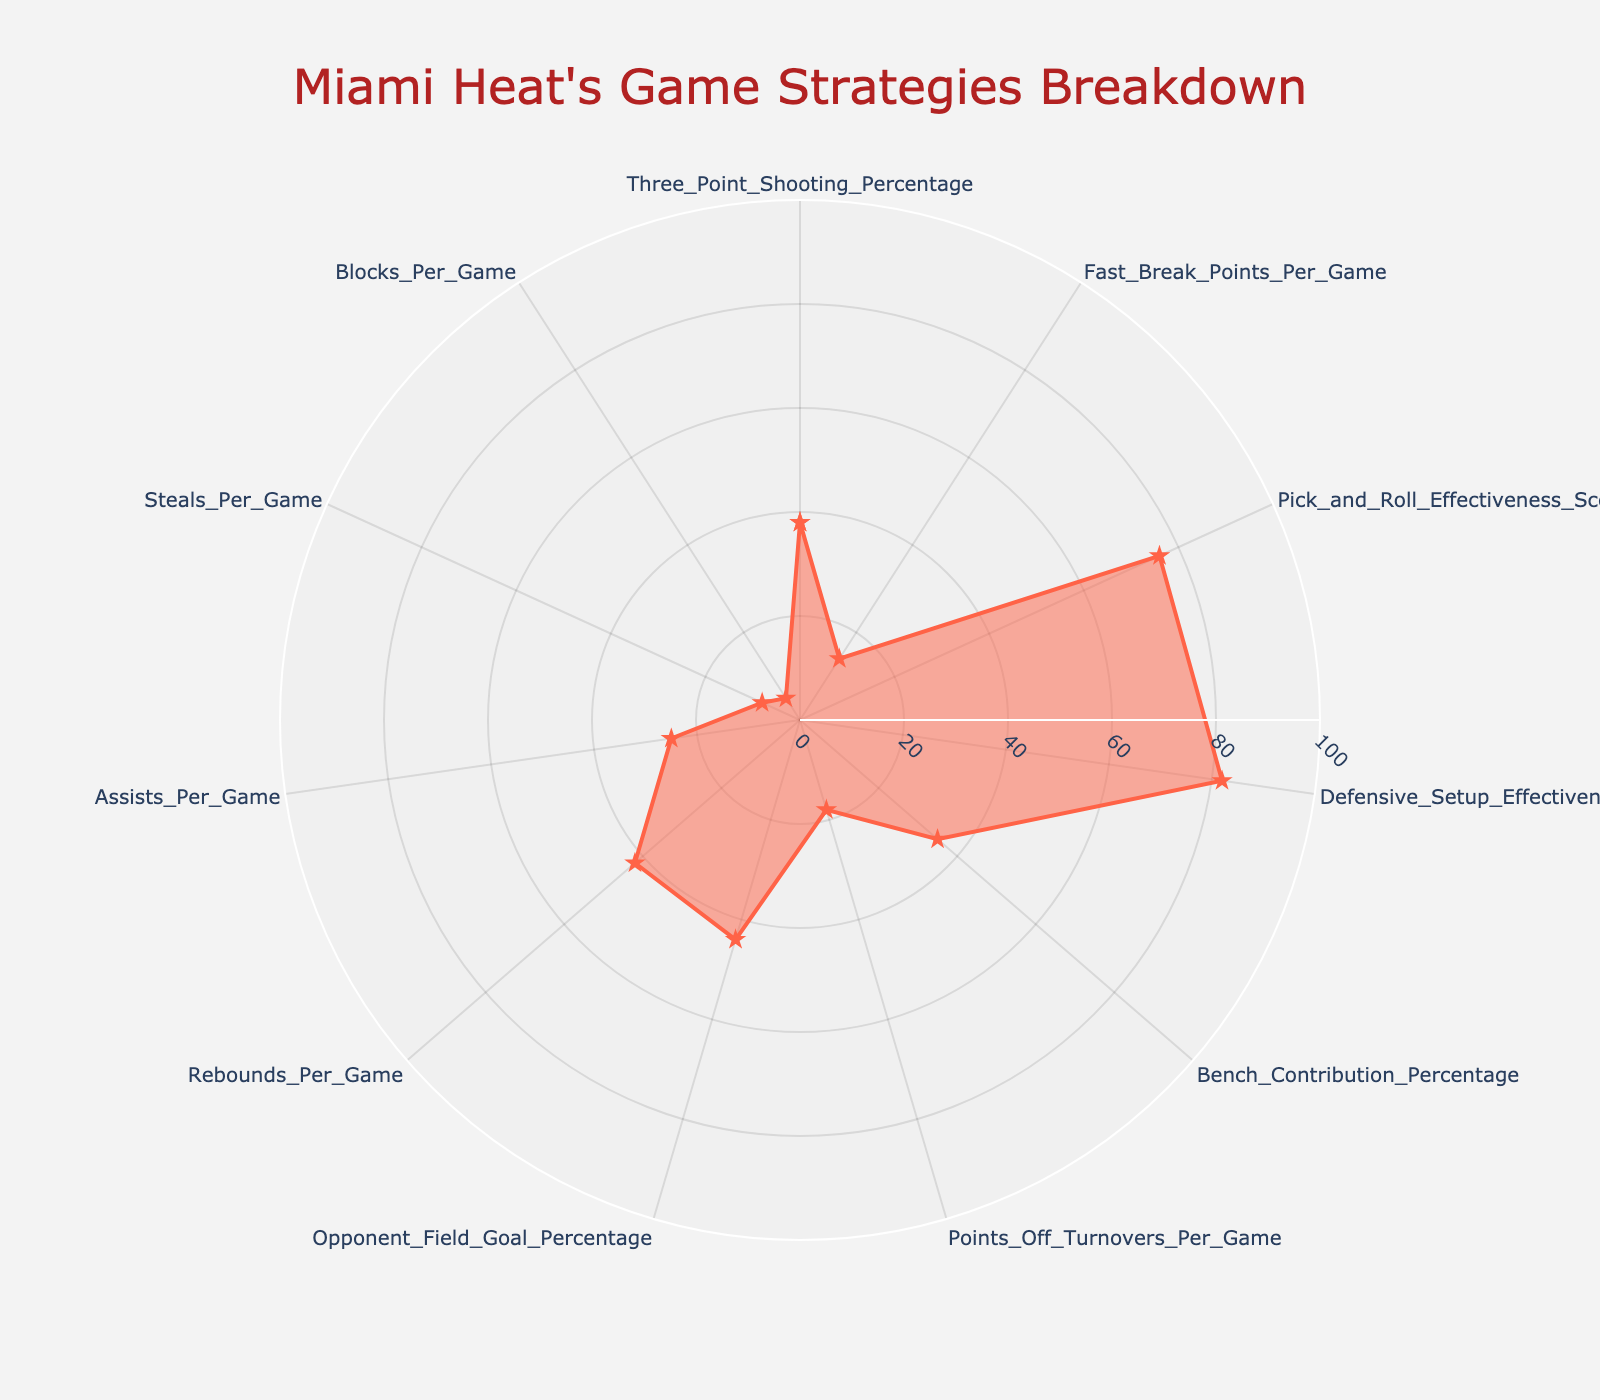What's the title of the radar chart? The title of the radar chart is usually located at the top center of the figure and provides a brief description of what the chart represents. In this case, it reads "Miami Heat's Game Strategies Breakdown".
Answer: Miami Heat's Game Strategies Breakdown What is the value of the Miami Heat's Three-Point Shooting Percentage? Locate the section labeled "Three_Point_Shooting_Percentage" and read the corresponding value marked by the point on the radar chart along the axis.
Answer: 38 Which category has the highest value in the radar chart? Examine the values provided for each category. The one with the highest value is the one extending the furthest from the center of the radar chart. The highest value here is "Defensive_Setup_Effectiveness" with a value of 82.
Answer: Defensive_Setup_Effectiveness How many categories are displayed in the radar chart? Count the distinct categories labeled around the radar chart. Note that the chart starts and ends with the same category to close the polygon. Exclude the last repeated category.
Answer: 11 What are the categories with values above 50? Check the value for each category listed on the radar chart. The categories "Pick_and_Roll_Effectiveness_Score" (76) and "Defensive_Setup_Effectiveness" (82), and "Assists_Per_Game" (25) must be identified as above 50.
Answer: Pick_and_Roll_Effectiveness_Score, Defensive_Setup_Effectiveness By how much does the Opponent Field Goal Percentage exceed the Points Off Turnovers Per Game? Subtract the value for "Points_Off_Turnovers_Per_Game" (18) from the value for "Opponent_Field_Goal_Percentage" (44). The difference is 26.
Answer: 26 Compare Bench Contribution Percentage with Rebounds Per Game, which is greater? Look at the values for "Bench_Contribution_Percentage" (35) and "Rebounds_Per_Game" (42). The category with the higher value is "Rebounds_Per_Game".
Answer: Rebounds_Per_Game What's the difference between the highest and lowest values in the chart? Identify the highest value (82 for "Defensive_Setup_Effectiveness") and the lowest value (5 for "Blocks_Per_Game"), and subtract the lowest from the highest: 82 - 5 = 77.
Answer: 77 Is Miami Heat's Fast Break Points Per Game higher or lower than Blocks Per Game? Compare the values for "Fast_Break_Points_Per_Game" (14) and "Blocks_Per_Game" (5). The value for "Fast_Break_Points_Per_Game" is higher.
Answer: Higher What can you infer about Miami Heat's defensive performance based on the chart? Consider the values related to defense such as "Defensive_Setup_Effectiveness" (82), "Opponent_Field_Goal_Percentage" (44), "Steals_Per_Game" (8), and "Blocks_Per_Game" (5). Higher values in "Defensive_Setup_Effectiveness" and a relatively low "Opponent_Field_Goal_Percentage" indicate a strong defensive performance.
Answer: Strong defensive performance 